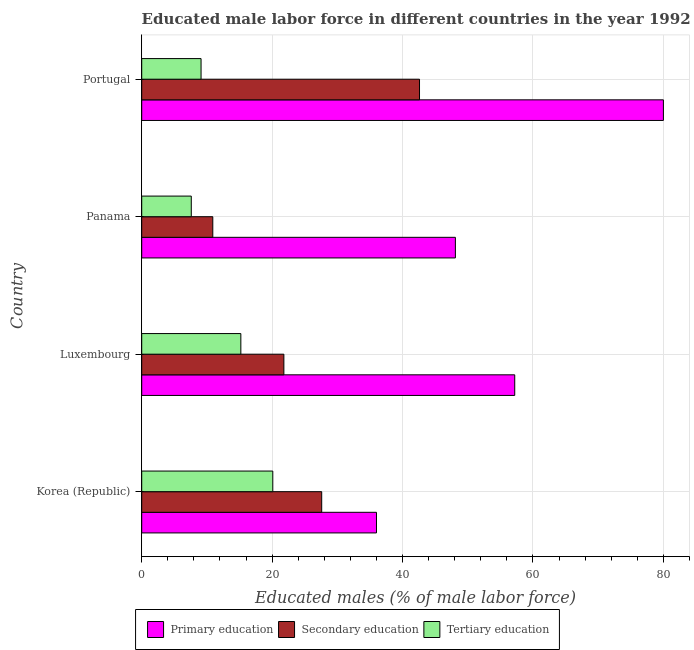Are the number of bars on each tick of the Y-axis equal?
Provide a short and direct response. Yes. What is the label of the 1st group of bars from the top?
Ensure brevity in your answer.  Portugal. In how many cases, is the number of bars for a given country not equal to the number of legend labels?
Your answer should be very brief. 0. What is the percentage of male labor force who received primary education in Luxembourg?
Provide a short and direct response. 57.2. Across all countries, what is the maximum percentage of male labor force who received tertiary education?
Offer a terse response. 20.1. Across all countries, what is the minimum percentage of male labor force who received secondary education?
Ensure brevity in your answer.  10.9. In which country was the percentage of male labor force who received tertiary education maximum?
Offer a terse response. Korea (Republic). What is the total percentage of male labor force who received tertiary education in the graph?
Provide a succinct answer. 52. What is the difference between the percentage of male labor force who received tertiary education in Korea (Republic) and that in Panama?
Offer a very short reply. 12.5. What is the difference between the percentage of male labor force who received tertiary education in Luxembourg and the percentage of male labor force who received secondary education in Portugal?
Offer a terse response. -27.4. What is the difference between the percentage of male labor force who received secondary education and percentage of male labor force who received tertiary education in Portugal?
Keep it short and to the point. 33.5. In how many countries, is the percentage of male labor force who received tertiary education greater than 12 %?
Offer a terse response. 2. What is the ratio of the percentage of male labor force who received primary education in Luxembourg to that in Panama?
Offer a terse response. 1.19. What is the difference between the highest and the lowest percentage of male labor force who received secondary education?
Keep it short and to the point. 31.7. Is the sum of the percentage of male labor force who received primary education in Korea (Republic) and Portugal greater than the maximum percentage of male labor force who received tertiary education across all countries?
Give a very brief answer. Yes. What does the 2nd bar from the top in Portugal represents?
Offer a terse response. Secondary education. What does the 3rd bar from the bottom in Portugal represents?
Offer a very short reply. Tertiary education. What is the difference between two consecutive major ticks on the X-axis?
Keep it short and to the point. 20. Are the values on the major ticks of X-axis written in scientific E-notation?
Ensure brevity in your answer.  No. Does the graph contain any zero values?
Make the answer very short. No. Does the graph contain grids?
Provide a short and direct response. Yes. Where does the legend appear in the graph?
Keep it short and to the point. Bottom center. How are the legend labels stacked?
Provide a short and direct response. Horizontal. What is the title of the graph?
Provide a short and direct response. Educated male labor force in different countries in the year 1992. Does "Oil sources" appear as one of the legend labels in the graph?
Offer a terse response. No. What is the label or title of the X-axis?
Your answer should be very brief. Educated males (% of male labor force). What is the label or title of the Y-axis?
Give a very brief answer. Country. What is the Educated males (% of male labor force) in Primary education in Korea (Republic)?
Offer a very short reply. 36. What is the Educated males (% of male labor force) in Secondary education in Korea (Republic)?
Ensure brevity in your answer.  27.6. What is the Educated males (% of male labor force) of Tertiary education in Korea (Republic)?
Provide a short and direct response. 20.1. What is the Educated males (% of male labor force) in Primary education in Luxembourg?
Ensure brevity in your answer.  57.2. What is the Educated males (% of male labor force) of Secondary education in Luxembourg?
Offer a terse response. 21.8. What is the Educated males (% of male labor force) of Tertiary education in Luxembourg?
Make the answer very short. 15.2. What is the Educated males (% of male labor force) of Primary education in Panama?
Give a very brief answer. 48.1. What is the Educated males (% of male labor force) in Secondary education in Panama?
Your response must be concise. 10.9. What is the Educated males (% of male labor force) of Tertiary education in Panama?
Keep it short and to the point. 7.6. What is the Educated males (% of male labor force) in Primary education in Portugal?
Ensure brevity in your answer.  80. What is the Educated males (% of male labor force) in Secondary education in Portugal?
Provide a succinct answer. 42.6. What is the Educated males (% of male labor force) in Tertiary education in Portugal?
Your answer should be very brief. 9.1. Across all countries, what is the maximum Educated males (% of male labor force) in Secondary education?
Make the answer very short. 42.6. Across all countries, what is the maximum Educated males (% of male labor force) in Tertiary education?
Provide a succinct answer. 20.1. Across all countries, what is the minimum Educated males (% of male labor force) of Secondary education?
Offer a terse response. 10.9. Across all countries, what is the minimum Educated males (% of male labor force) of Tertiary education?
Give a very brief answer. 7.6. What is the total Educated males (% of male labor force) of Primary education in the graph?
Provide a succinct answer. 221.3. What is the total Educated males (% of male labor force) in Secondary education in the graph?
Your answer should be compact. 102.9. What is the difference between the Educated males (% of male labor force) of Primary education in Korea (Republic) and that in Luxembourg?
Provide a succinct answer. -21.2. What is the difference between the Educated males (% of male labor force) in Primary education in Korea (Republic) and that in Panama?
Offer a terse response. -12.1. What is the difference between the Educated males (% of male labor force) of Tertiary education in Korea (Republic) and that in Panama?
Offer a terse response. 12.5. What is the difference between the Educated males (% of male labor force) of Primary education in Korea (Republic) and that in Portugal?
Keep it short and to the point. -44. What is the difference between the Educated males (% of male labor force) of Tertiary education in Korea (Republic) and that in Portugal?
Your answer should be compact. 11. What is the difference between the Educated males (% of male labor force) of Primary education in Luxembourg and that in Panama?
Ensure brevity in your answer.  9.1. What is the difference between the Educated males (% of male labor force) of Secondary education in Luxembourg and that in Panama?
Make the answer very short. 10.9. What is the difference between the Educated males (% of male labor force) in Primary education in Luxembourg and that in Portugal?
Offer a very short reply. -22.8. What is the difference between the Educated males (% of male labor force) in Secondary education in Luxembourg and that in Portugal?
Make the answer very short. -20.8. What is the difference between the Educated males (% of male labor force) in Primary education in Panama and that in Portugal?
Keep it short and to the point. -31.9. What is the difference between the Educated males (% of male labor force) in Secondary education in Panama and that in Portugal?
Offer a very short reply. -31.7. What is the difference between the Educated males (% of male labor force) of Tertiary education in Panama and that in Portugal?
Make the answer very short. -1.5. What is the difference between the Educated males (% of male labor force) in Primary education in Korea (Republic) and the Educated males (% of male labor force) in Secondary education in Luxembourg?
Offer a very short reply. 14.2. What is the difference between the Educated males (% of male labor force) in Primary education in Korea (Republic) and the Educated males (% of male labor force) in Tertiary education in Luxembourg?
Offer a very short reply. 20.8. What is the difference between the Educated males (% of male labor force) in Secondary education in Korea (Republic) and the Educated males (% of male labor force) in Tertiary education in Luxembourg?
Offer a very short reply. 12.4. What is the difference between the Educated males (% of male labor force) in Primary education in Korea (Republic) and the Educated males (% of male labor force) in Secondary education in Panama?
Your response must be concise. 25.1. What is the difference between the Educated males (% of male labor force) of Primary education in Korea (Republic) and the Educated males (% of male labor force) of Tertiary education in Panama?
Your answer should be compact. 28.4. What is the difference between the Educated males (% of male labor force) of Primary education in Korea (Republic) and the Educated males (% of male labor force) of Secondary education in Portugal?
Your response must be concise. -6.6. What is the difference between the Educated males (% of male labor force) of Primary education in Korea (Republic) and the Educated males (% of male labor force) of Tertiary education in Portugal?
Your response must be concise. 26.9. What is the difference between the Educated males (% of male labor force) in Secondary education in Korea (Republic) and the Educated males (% of male labor force) in Tertiary education in Portugal?
Provide a short and direct response. 18.5. What is the difference between the Educated males (% of male labor force) of Primary education in Luxembourg and the Educated males (% of male labor force) of Secondary education in Panama?
Give a very brief answer. 46.3. What is the difference between the Educated males (% of male labor force) in Primary education in Luxembourg and the Educated males (% of male labor force) in Tertiary education in Panama?
Your response must be concise. 49.6. What is the difference between the Educated males (% of male labor force) of Primary education in Luxembourg and the Educated males (% of male labor force) of Secondary education in Portugal?
Your response must be concise. 14.6. What is the difference between the Educated males (% of male labor force) of Primary education in Luxembourg and the Educated males (% of male labor force) of Tertiary education in Portugal?
Offer a terse response. 48.1. What is the difference between the Educated males (% of male labor force) of Primary education in Panama and the Educated males (% of male labor force) of Secondary education in Portugal?
Make the answer very short. 5.5. What is the difference between the Educated males (% of male labor force) of Primary education in Panama and the Educated males (% of male labor force) of Tertiary education in Portugal?
Your response must be concise. 39. What is the average Educated males (% of male labor force) of Primary education per country?
Ensure brevity in your answer.  55.33. What is the average Educated males (% of male labor force) of Secondary education per country?
Offer a very short reply. 25.73. What is the average Educated males (% of male labor force) of Tertiary education per country?
Your answer should be compact. 13. What is the difference between the Educated males (% of male labor force) of Primary education and Educated males (% of male labor force) of Secondary education in Korea (Republic)?
Provide a succinct answer. 8.4. What is the difference between the Educated males (% of male labor force) of Primary education and Educated males (% of male labor force) of Tertiary education in Korea (Republic)?
Keep it short and to the point. 15.9. What is the difference between the Educated males (% of male labor force) in Secondary education and Educated males (% of male labor force) in Tertiary education in Korea (Republic)?
Your answer should be very brief. 7.5. What is the difference between the Educated males (% of male labor force) in Primary education and Educated males (% of male labor force) in Secondary education in Luxembourg?
Offer a terse response. 35.4. What is the difference between the Educated males (% of male labor force) in Primary education and Educated males (% of male labor force) in Secondary education in Panama?
Ensure brevity in your answer.  37.2. What is the difference between the Educated males (% of male labor force) in Primary education and Educated males (% of male labor force) in Tertiary education in Panama?
Your answer should be compact. 40.5. What is the difference between the Educated males (% of male labor force) of Secondary education and Educated males (% of male labor force) of Tertiary education in Panama?
Your answer should be compact. 3.3. What is the difference between the Educated males (% of male labor force) in Primary education and Educated males (% of male labor force) in Secondary education in Portugal?
Ensure brevity in your answer.  37.4. What is the difference between the Educated males (% of male labor force) in Primary education and Educated males (% of male labor force) in Tertiary education in Portugal?
Give a very brief answer. 70.9. What is the difference between the Educated males (% of male labor force) of Secondary education and Educated males (% of male labor force) of Tertiary education in Portugal?
Your answer should be very brief. 33.5. What is the ratio of the Educated males (% of male labor force) of Primary education in Korea (Republic) to that in Luxembourg?
Provide a succinct answer. 0.63. What is the ratio of the Educated males (% of male labor force) of Secondary education in Korea (Republic) to that in Luxembourg?
Your answer should be very brief. 1.27. What is the ratio of the Educated males (% of male labor force) in Tertiary education in Korea (Republic) to that in Luxembourg?
Keep it short and to the point. 1.32. What is the ratio of the Educated males (% of male labor force) of Primary education in Korea (Republic) to that in Panama?
Keep it short and to the point. 0.75. What is the ratio of the Educated males (% of male labor force) of Secondary education in Korea (Republic) to that in Panama?
Make the answer very short. 2.53. What is the ratio of the Educated males (% of male labor force) of Tertiary education in Korea (Republic) to that in Panama?
Provide a succinct answer. 2.64. What is the ratio of the Educated males (% of male labor force) in Primary education in Korea (Republic) to that in Portugal?
Your answer should be very brief. 0.45. What is the ratio of the Educated males (% of male labor force) of Secondary education in Korea (Republic) to that in Portugal?
Provide a succinct answer. 0.65. What is the ratio of the Educated males (% of male labor force) of Tertiary education in Korea (Republic) to that in Portugal?
Make the answer very short. 2.21. What is the ratio of the Educated males (% of male labor force) in Primary education in Luxembourg to that in Panama?
Your answer should be compact. 1.19. What is the ratio of the Educated males (% of male labor force) in Secondary education in Luxembourg to that in Panama?
Make the answer very short. 2. What is the ratio of the Educated males (% of male labor force) of Tertiary education in Luxembourg to that in Panama?
Your answer should be compact. 2. What is the ratio of the Educated males (% of male labor force) in Primary education in Luxembourg to that in Portugal?
Provide a succinct answer. 0.71. What is the ratio of the Educated males (% of male labor force) of Secondary education in Luxembourg to that in Portugal?
Your response must be concise. 0.51. What is the ratio of the Educated males (% of male labor force) in Tertiary education in Luxembourg to that in Portugal?
Your answer should be very brief. 1.67. What is the ratio of the Educated males (% of male labor force) of Primary education in Panama to that in Portugal?
Provide a short and direct response. 0.6. What is the ratio of the Educated males (% of male labor force) in Secondary education in Panama to that in Portugal?
Offer a terse response. 0.26. What is the ratio of the Educated males (% of male labor force) in Tertiary education in Panama to that in Portugal?
Give a very brief answer. 0.84. What is the difference between the highest and the second highest Educated males (% of male labor force) of Primary education?
Give a very brief answer. 22.8. What is the difference between the highest and the second highest Educated males (% of male labor force) in Tertiary education?
Your response must be concise. 4.9. What is the difference between the highest and the lowest Educated males (% of male labor force) in Secondary education?
Provide a short and direct response. 31.7. What is the difference between the highest and the lowest Educated males (% of male labor force) of Tertiary education?
Keep it short and to the point. 12.5. 